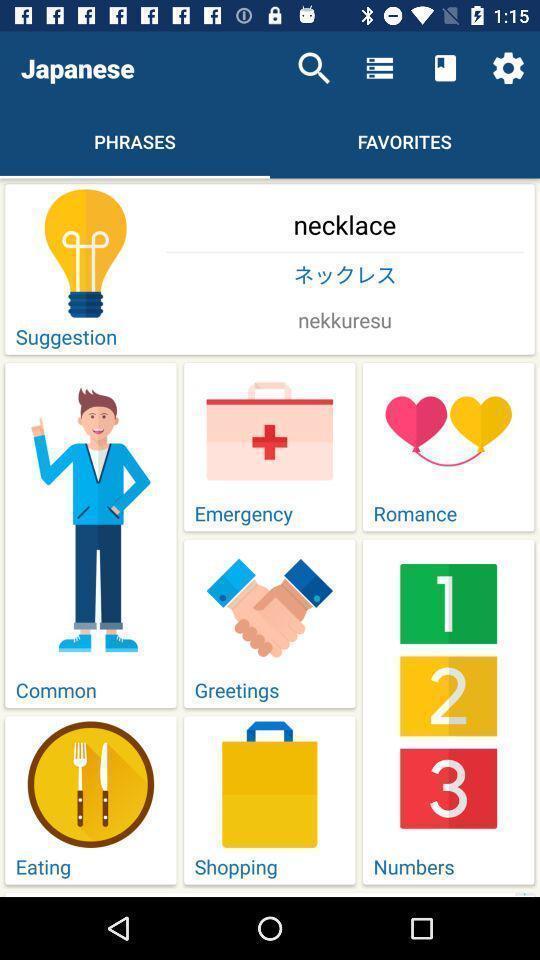Explain what's happening in this screen capture. Screen page displaying various categories in learning app. 